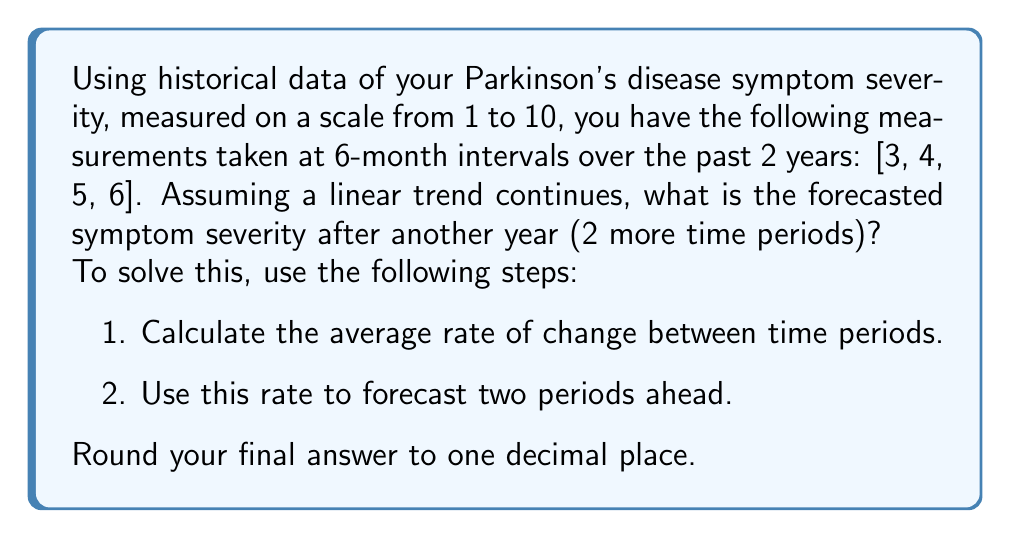Solve this math problem. Let's approach this step-by-step:

1) First, we need to calculate the average rate of change between time periods.

   We have 4 data points: [3, 4, 5, 6]
   
   The differences between consecutive points are:
   4 - 3 = 1
   5 - 4 = 1
   6 - 5 = 1

   The average rate of change is:
   $$ \text{Average Rate} = \frac{1 + 1 + 1}{3} = 1 $$

2) Now that we have the average rate of change, we can use it to forecast future values.

   The last observed value is 6.
   We want to forecast 2 time periods ahead.

   The forecasted value will be:
   $$ \text{Forecast} = 6 + (1 \times 2) = 8 $$

   Where 6 is the last observed value, 1 is the average rate of change, and 2 is the number of time periods we're forecasting ahead.

This linear forecasting method assumes that the trend observed in the historical data will continue in the future. However, it's important to note that in reality, disease progression may not always follow a linear pattern and could be influenced by various factors such as medication, lifestyle changes, and individual variability.
Answer: 8.0 